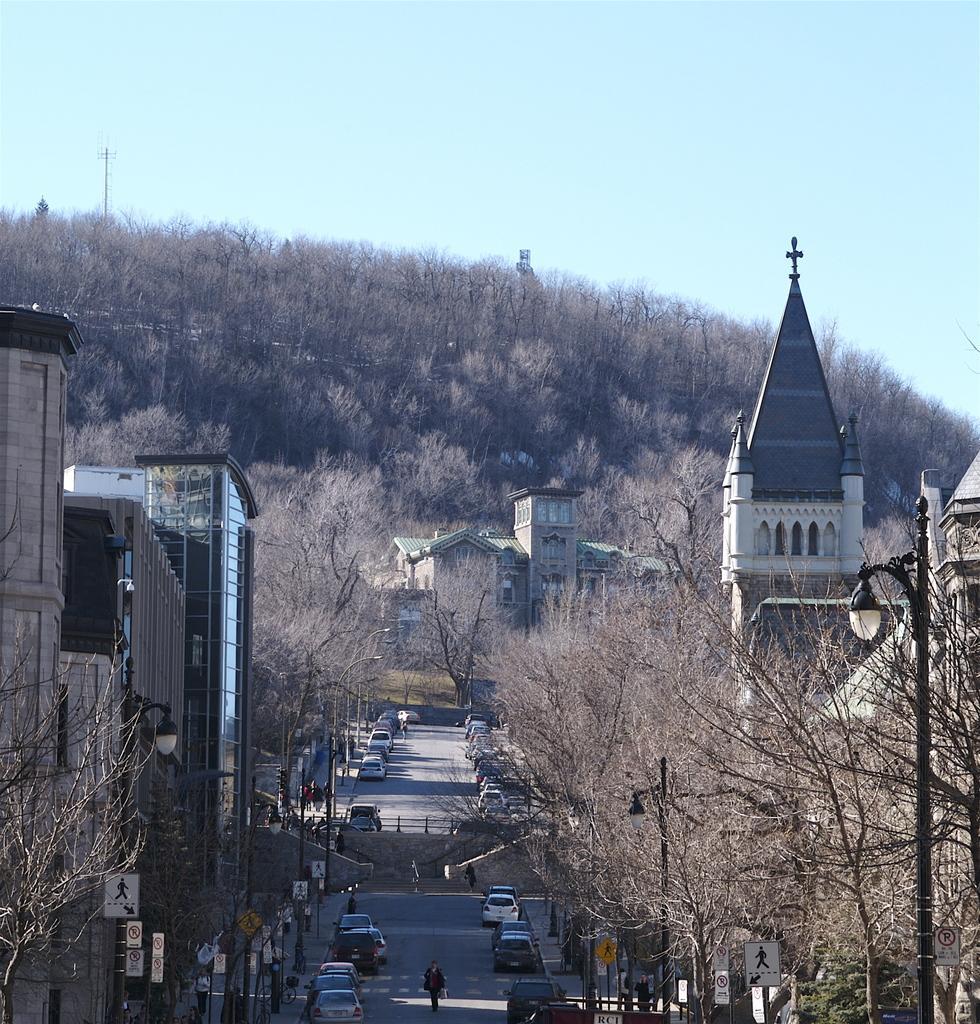Describe this image in one or two sentences. In this image I can see buildings, trees, cars and people on the road. In the background I can see the sky. Here I can see street lights and sign boards. 